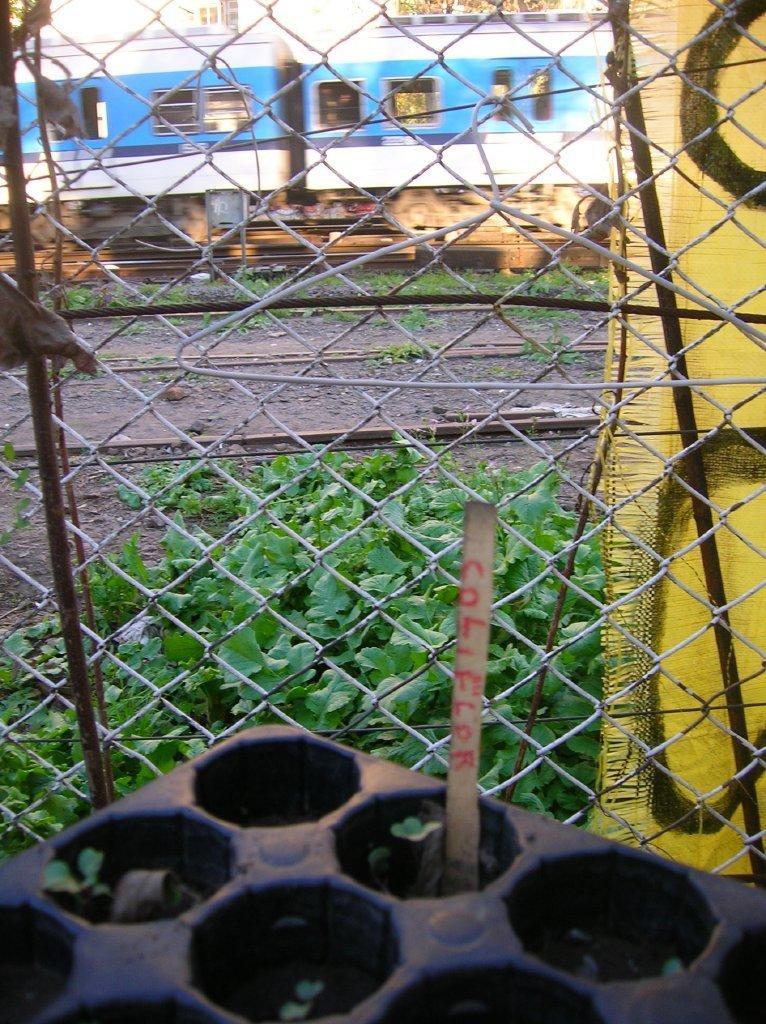Can you describe this image briefly? There is a black color object in the left corner and there is a fence in front of it and there is a train on the track in the background. 